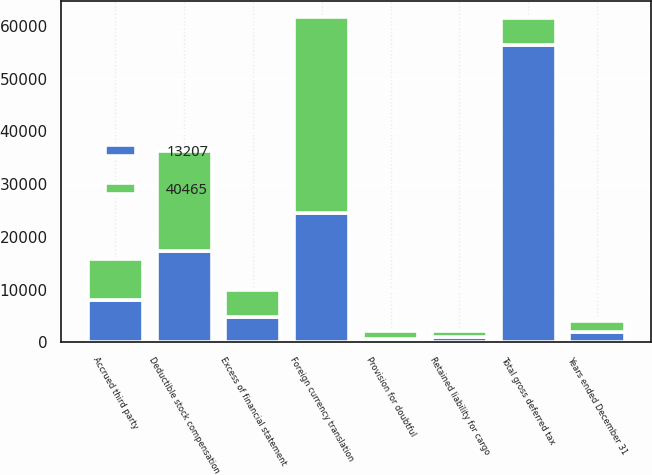Convert chart. <chart><loc_0><loc_0><loc_500><loc_500><stacked_bar_chart><ecel><fcel>Years ended December 31<fcel>Accrued third party<fcel>Provision for doubtful<fcel>Excess of financial statement<fcel>Deductible stock compensation<fcel>Foreign currency translation<fcel>Retained liability for cargo<fcel>Total gross deferred tax<nl><fcel>40465<fcel>2018<fcel>7726<fcel>1443<fcel>5134<fcel>19011<fcel>37299<fcel>1025<fcel>5134<nl><fcel>13207<fcel>2017<fcel>8075<fcel>628<fcel>4804<fcel>17326<fcel>24448<fcel>1062<fcel>56343<nl></chart> 